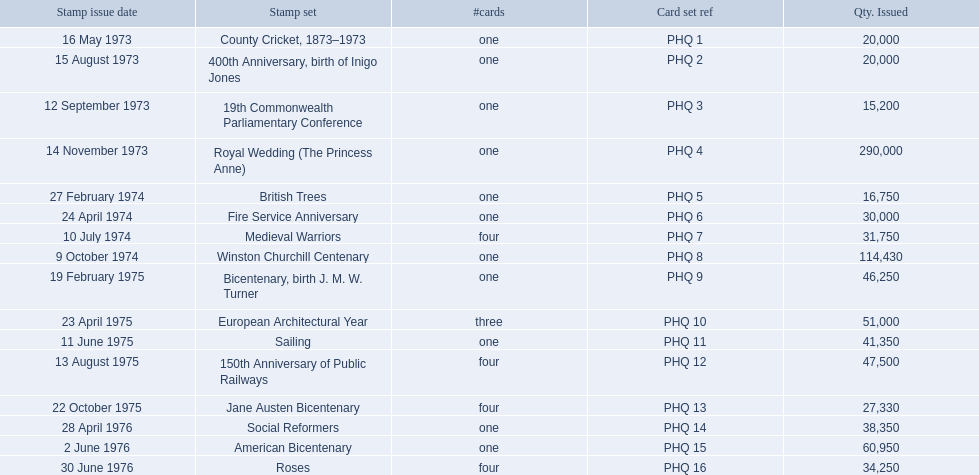Which stamp collections included three or more cards? Medieval Warriors, European Architectural Year, 150th Anniversary of Public Railways, Jane Austen Bicentenary, Roses. Among them, which one consists of only three cards? European Architectural Year. What are all the stamp assortments? County Cricket, 1873–1973, 400th Anniversary, birth of Inigo Jones, 19th Commonwealth Parliamentary Conference, Royal Wedding (The Princess Anne), British Trees, Fire Service Anniversary, Medieval Warriors, Winston Churchill Centenary, Bicentenary, birth J. M. W. Turner, European Architectural Year, Sailing, 150th Anniversary of Public Railways, Jane Austen Bicentenary, Social Reformers, American Bicentenary, Roses. Which of these assortments has three cards in it? European Architectural Year. 